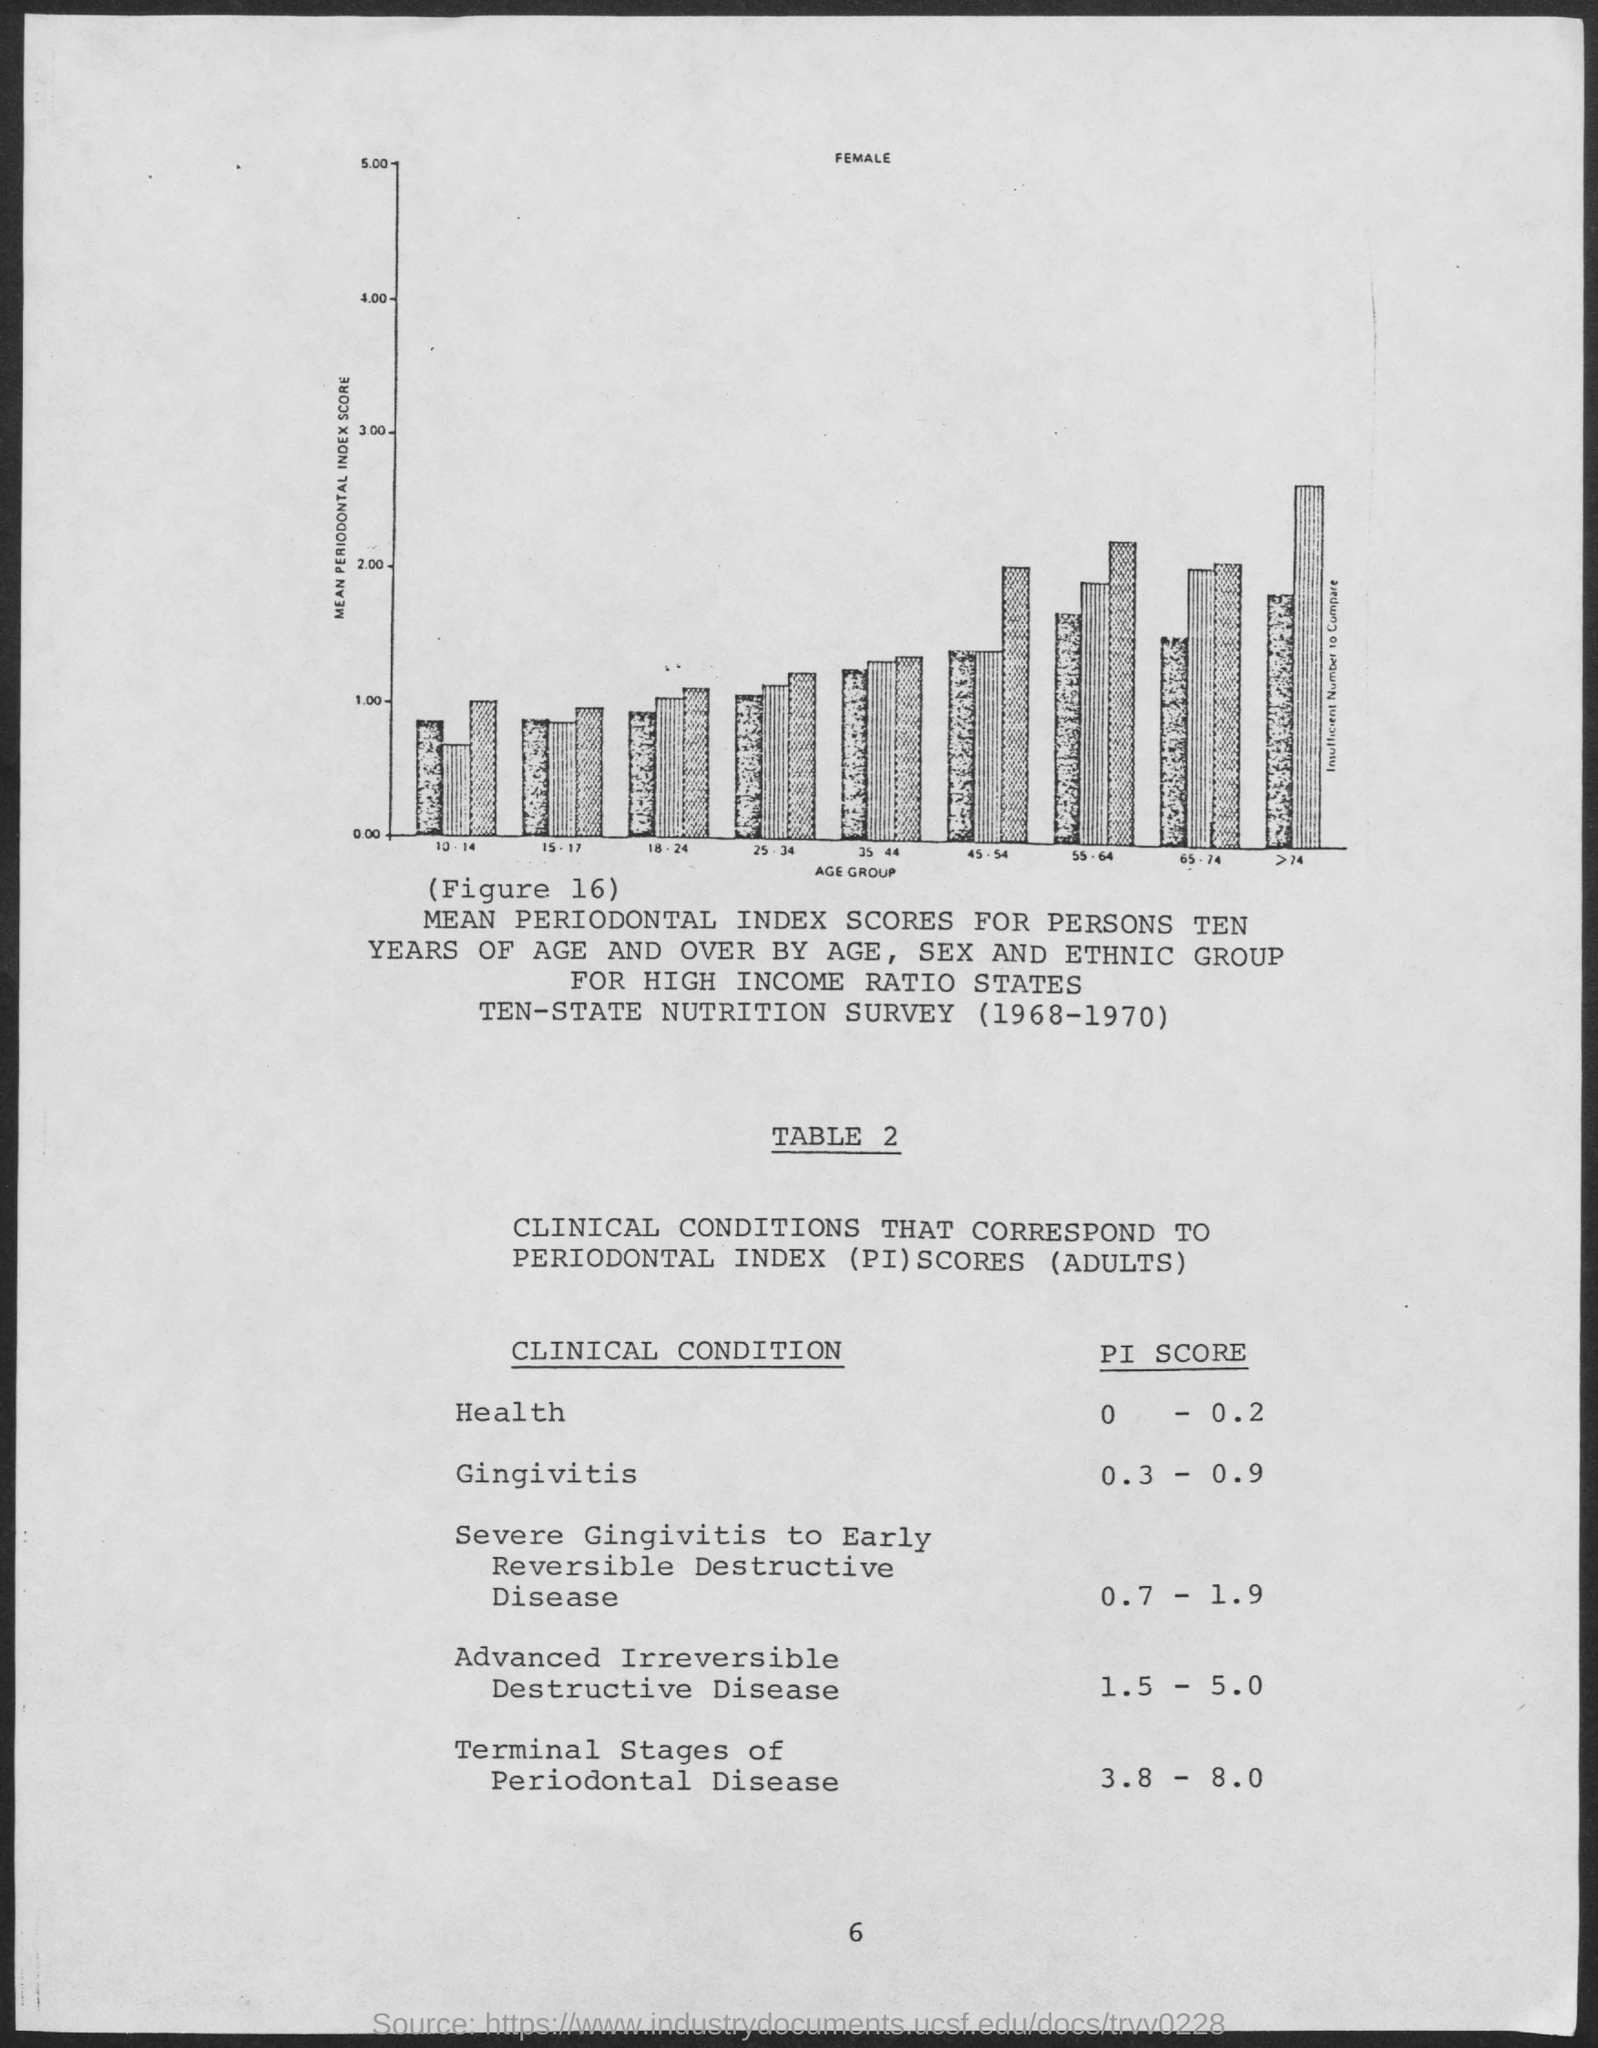Identify some key points in this picture. The Pi score for gingivitis ranges from 0.3 to 0.9. The Pi score for health ranges from 0 to 0.2, with lower values indicating poorer health. The Pi score ranges from 3.8 to 8.0 for the terminal stages of periodontal disease. The Pi score for advanced irreversible destructive disease ranges from 1.5 to 5.0. 